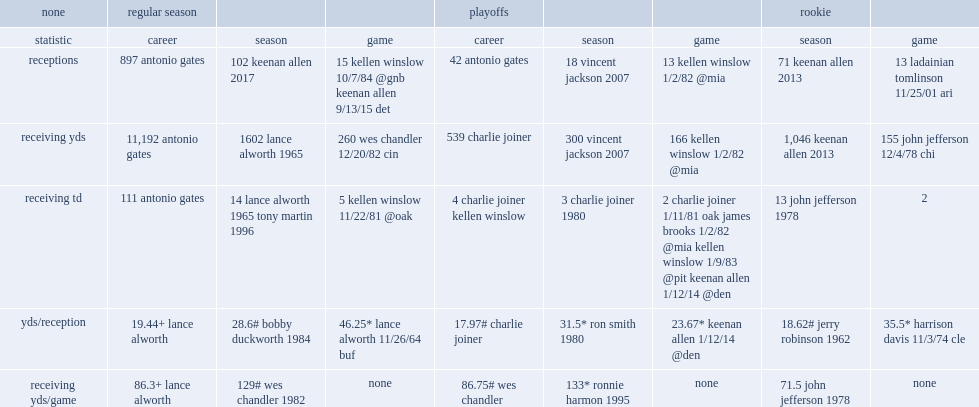How many receiving yards per game in regular season did chandler get? 129# wes chandler 1982. 